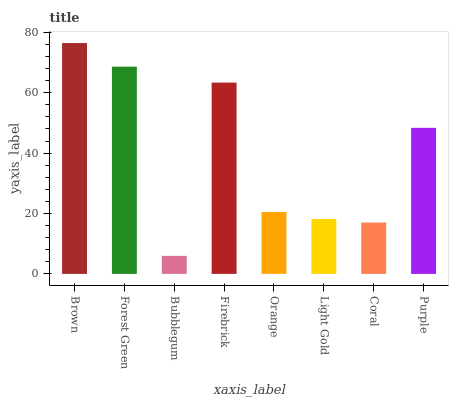Is Bubblegum the minimum?
Answer yes or no. Yes. Is Brown the maximum?
Answer yes or no. Yes. Is Forest Green the minimum?
Answer yes or no. No. Is Forest Green the maximum?
Answer yes or no. No. Is Brown greater than Forest Green?
Answer yes or no. Yes. Is Forest Green less than Brown?
Answer yes or no. Yes. Is Forest Green greater than Brown?
Answer yes or no. No. Is Brown less than Forest Green?
Answer yes or no. No. Is Purple the high median?
Answer yes or no. Yes. Is Orange the low median?
Answer yes or no. Yes. Is Bubblegum the high median?
Answer yes or no. No. Is Bubblegum the low median?
Answer yes or no. No. 